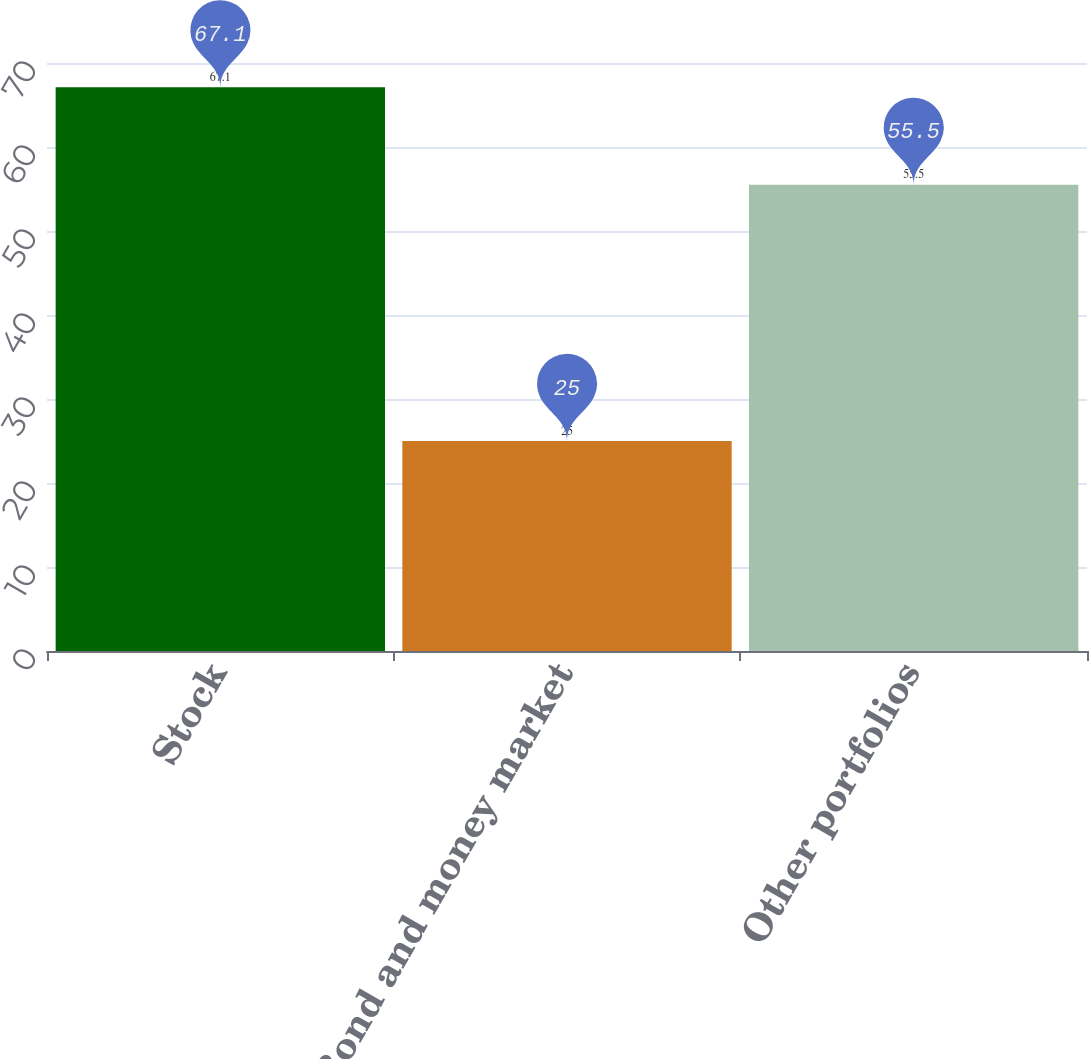<chart> <loc_0><loc_0><loc_500><loc_500><bar_chart><fcel>Stock<fcel>Bond and money market<fcel>Other portfolios<nl><fcel>67.1<fcel>25<fcel>55.5<nl></chart> 